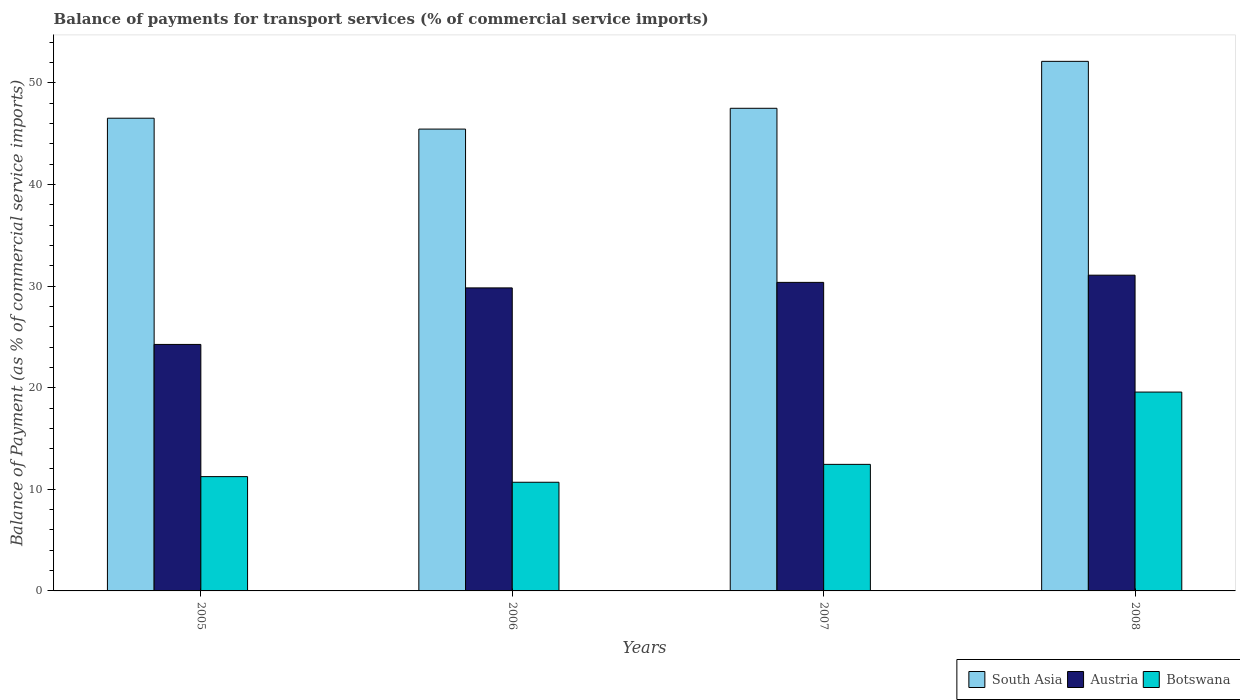How many groups of bars are there?
Keep it short and to the point. 4. Are the number of bars on each tick of the X-axis equal?
Make the answer very short. Yes. How many bars are there on the 1st tick from the left?
Your answer should be compact. 3. How many bars are there on the 4th tick from the right?
Provide a short and direct response. 3. What is the label of the 3rd group of bars from the left?
Ensure brevity in your answer.  2007. In how many cases, is the number of bars for a given year not equal to the number of legend labels?
Keep it short and to the point. 0. What is the balance of payments for transport services in South Asia in 2005?
Your response must be concise. 46.53. Across all years, what is the maximum balance of payments for transport services in South Asia?
Provide a succinct answer. 52.12. Across all years, what is the minimum balance of payments for transport services in South Asia?
Keep it short and to the point. 45.46. In which year was the balance of payments for transport services in South Asia maximum?
Make the answer very short. 2008. In which year was the balance of payments for transport services in Botswana minimum?
Give a very brief answer. 2006. What is the total balance of payments for transport services in South Asia in the graph?
Keep it short and to the point. 191.6. What is the difference between the balance of payments for transport services in Austria in 2006 and that in 2007?
Provide a succinct answer. -0.54. What is the difference between the balance of payments for transport services in Austria in 2008 and the balance of payments for transport services in Botswana in 2006?
Make the answer very short. 20.38. What is the average balance of payments for transport services in Austria per year?
Ensure brevity in your answer.  28.88. In the year 2007, what is the difference between the balance of payments for transport services in Austria and balance of payments for transport services in South Asia?
Keep it short and to the point. -17.14. In how many years, is the balance of payments for transport services in South Asia greater than 6 %?
Ensure brevity in your answer.  4. What is the ratio of the balance of payments for transport services in Austria in 2006 to that in 2007?
Your answer should be very brief. 0.98. What is the difference between the highest and the second highest balance of payments for transport services in Austria?
Your response must be concise. 0.71. What is the difference between the highest and the lowest balance of payments for transport services in Botswana?
Offer a terse response. 8.88. In how many years, is the balance of payments for transport services in Austria greater than the average balance of payments for transport services in Austria taken over all years?
Ensure brevity in your answer.  3. Is the sum of the balance of payments for transport services in Austria in 2006 and 2008 greater than the maximum balance of payments for transport services in South Asia across all years?
Offer a terse response. Yes. What does the 3rd bar from the right in 2007 represents?
Offer a terse response. South Asia. How many bars are there?
Offer a very short reply. 12. How many years are there in the graph?
Provide a short and direct response. 4. Are the values on the major ticks of Y-axis written in scientific E-notation?
Your answer should be very brief. No. Does the graph contain any zero values?
Provide a short and direct response. No. How many legend labels are there?
Make the answer very short. 3. What is the title of the graph?
Ensure brevity in your answer.  Balance of payments for transport services (% of commercial service imports). Does "Iceland" appear as one of the legend labels in the graph?
Your response must be concise. No. What is the label or title of the Y-axis?
Make the answer very short. Balance of Payment (as % of commercial service imports). What is the Balance of Payment (as % of commercial service imports) of South Asia in 2005?
Ensure brevity in your answer.  46.53. What is the Balance of Payment (as % of commercial service imports) of Austria in 2005?
Your answer should be very brief. 24.26. What is the Balance of Payment (as % of commercial service imports) in Botswana in 2005?
Offer a terse response. 11.25. What is the Balance of Payment (as % of commercial service imports) in South Asia in 2006?
Offer a very short reply. 45.46. What is the Balance of Payment (as % of commercial service imports) in Austria in 2006?
Your answer should be very brief. 29.82. What is the Balance of Payment (as % of commercial service imports) in Botswana in 2006?
Your answer should be compact. 10.7. What is the Balance of Payment (as % of commercial service imports) in South Asia in 2007?
Your answer should be compact. 47.5. What is the Balance of Payment (as % of commercial service imports) of Austria in 2007?
Make the answer very short. 30.37. What is the Balance of Payment (as % of commercial service imports) in Botswana in 2007?
Ensure brevity in your answer.  12.46. What is the Balance of Payment (as % of commercial service imports) in South Asia in 2008?
Your response must be concise. 52.12. What is the Balance of Payment (as % of commercial service imports) of Austria in 2008?
Ensure brevity in your answer.  31.08. What is the Balance of Payment (as % of commercial service imports) of Botswana in 2008?
Your answer should be compact. 19.57. Across all years, what is the maximum Balance of Payment (as % of commercial service imports) in South Asia?
Your answer should be compact. 52.12. Across all years, what is the maximum Balance of Payment (as % of commercial service imports) of Austria?
Keep it short and to the point. 31.08. Across all years, what is the maximum Balance of Payment (as % of commercial service imports) of Botswana?
Offer a very short reply. 19.57. Across all years, what is the minimum Balance of Payment (as % of commercial service imports) of South Asia?
Your answer should be very brief. 45.46. Across all years, what is the minimum Balance of Payment (as % of commercial service imports) in Austria?
Provide a short and direct response. 24.26. Across all years, what is the minimum Balance of Payment (as % of commercial service imports) in Botswana?
Your answer should be compact. 10.7. What is the total Balance of Payment (as % of commercial service imports) in South Asia in the graph?
Ensure brevity in your answer.  191.6. What is the total Balance of Payment (as % of commercial service imports) of Austria in the graph?
Your answer should be compact. 115.53. What is the total Balance of Payment (as % of commercial service imports) of Botswana in the graph?
Your response must be concise. 53.97. What is the difference between the Balance of Payment (as % of commercial service imports) of South Asia in 2005 and that in 2006?
Offer a very short reply. 1.07. What is the difference between the Balance of Payment (as % of commercial service imports) of Austria in 2005 and that in 2006?
Provide a succinct answer. -5.56. What is the difference between the Balance of Payment (as % of commercial service imports) in Botswana in 2005 and that in 2006?
Offer a very short reply. 0.56. What is the difference between the Balance of Payment (as % of commercial service imports) in South Asia in 2005 and that in 2007?
Your response must be concise. -0.98. What is the difference between the Balance of Payment (as % of commercial service imports) of Austria in 2005 and that in 2007?
Your answer should be very brief. -6.11. What is the difference between the Balance of Payment (as % of commercial service imports) in Botswana in 2005 and that in 2007?
Your answer should be very brief. -1.21. What is the difference between the Balance of Payment (as % of commercial service imports) of South Asia in 2005 and that in 2008?
Keep it short and to the point. -5.6. What is the difference between the Balance of Payment (as % of commercial service imports) of Austria in 2005 and that in 2008?
Provide a short and direct response. -6.82. What is the difference between the Balance of Payment (as % of commercial service imports) of Botswana in 2005 and that in 2008?
Your answer should be very brief. -8.32. What is the difference between the Balance of Payment (as % of commercial service imports) in South Asia in 2006 and that in 2007?
Keep it short and to the point. -2.05. What is the difference between the Balance of Payment (as % of commercial service imports) in Austria in 2006 and that in 2007?
Offer a very short reply. -0.54. What is the difference between the Balance of Payment (as % of commercial service imports) in Botswana in 2006 and that in 2007?
Provide a succinct answer. -1.76. What is the difference between the Balance of Payment (as % of commercial service imports) of South Asia in 2006 and that in 2008?
Your response must be concise. -6.67. What is the difference between the Balance of Payment (as % of commercial service imports) in Austria in 2006 and that in 2008?
Your answer should be compact. -1.25. What is the difference between the Balance of Payment (as % of commercial service imports) in Botswana in 2006 and that in 2008?
Your response must be concise. -8.88. What is the difference between the Balance of Payment (as % of commercial service imports) in South Asia in 2007 and that in 2008?
Offer a very short reply. -4.62. What is the difference between the Balance of Payment (as % of commercial service imports) in Austria in 2007 and that in 2008?
Give a very brief answer. -0.71. What is the difference between the Balance of Payment (as % of commercial service imports) in Botswana in 2007 and that in 2008?
Your answer should be very brief. -7.12. What is the difference between the Balance of Payment (as % of commercial service imports) in South Asia in 2005 and the Balance of Payment (as % of commercial service imports) in Austria in 2006?
Your response must be concise. 16.7. What is the difference between the Balance of Payment (as % of commercial service imports) of South Asia in 2005 and the Balance of Payment (as % of commercial service imports) of Botswana in 2006?
Ensure brevity in your answer.  35.83. What is the difference between the Balance of Payment (as % of commercial service imports) in Austria in 2005 and the Balance of Payment (as % of commercial service imports) in Botswana in 2006?
Offer a terse response. 13.57. What is the difference between the Balance of Payment (as % of commercial service imports) of South Asia in 2005 and the Balance of Payment (as % of commercial service imports) of Austria in 2007?
Make the answer very short. 16.16. What is the difference between the Balance of Payment (as % of commercial service imports) in South Asia in 2005 and the Balance of Payment (as % of commercial service imports) in Botswana in 2007?
Provide a succinct answer. 34.07. What is the difference between the Balance of Payment (as % of commercial service imports) in Austria in 2005 and the Balance of Payment (as % of commercial service imports) in Botswana in 2007?
Provide a succinct answer. 11.8. What is the difference between the Balance of Payment (as % of commercial service imports) in South Asia in 2005 and the Balance of Payment (as % of commercial service imports) in Austria in 2008?
Ensure brevity in your answer.  15.45. What is the difference between the Balance of Payment (as % of commercial service imports) of South Asia in 2005 and the Balance of Payment (as % of commercial service imports) of Botswana in 2008?
Provide a short and direct response. 26.95. What is the difference between the Balance of Payment (as % of commercial service imports) in Austria in 2005 and the Balance of Payment (as % of commercial service imports) in Botswana in 2008?
Your answer should be compact. 4.69. What is the difference between the Balance of Payment (as % of commercial service imports) in South Asia in 2006 and the Balance of Payment (as % of commercial service imports) in Austria in 2007?
Offer a very short reply. 15.09. What is the difference between the Balance of Payment (as % of commercial service imports) in South Asia in 2006 and the Balance of Payment (as % of commercial service imports) in Botswana in 2007?
Make the answer very short. 33. What is the difference between the Balance of Payment (as % of commercial service imports) in Austria in 2006 and the Balance of Payment (as % of commercial service imports) in Botswana in 2007?
Ensure brevity in your answer.  17.37. What is the difference between the Balance of Payment (as % of commercial service imports) in South Asia in 2006 and the Balance of Payment (as % of commercial service imports) in Austria in 2008?
Your answer should be very brief. 14.38. What is the difference between the Balance of Payment (as % of commercial service imports) of South Asia in 2006 and the Balance of Payment (as % of commercial service imports) of Botswana in 2008?
Your answer should be compact. 25.88. What is the difference between the Balance of Payment (as % of commercial service imports) in Austria in 2006 and the Balance of Payment (as % of commercial service imports) in Botswana in 2008?
Offer a terse response. 10.25. What is the difference between the Balance of Payment (as % of commercial service imports) of South Asia in 2007 and the Balance of Payment (as % of commercial service imports) of Austria in 2008?
Your answer should be very brief. 16.43. What is the difference between the Balance of Payment (as % of commercial service imports) in South Asia in 2007 and the Balance of Payment (as % of commercial service imports) in Botswana in 2008?
Your answer should be compact. 27.93. What is the difference between the Balance of Payment (as % of commercial service imports) of Austria in 2007 and the Balance of Payment (as % of commercial service imports) of Botswana in 2008?
Make the answer very short. 10.79. What is the average Balance of Payment (as % of commercial service imports) of South Asia per year?
Ensure brevity in your answer.  47.9. What is the average Balance of Payment (as % of commercial service imports) in Austria per year?
Provide a short and direct response. 28.88. What is the average Balance of Payment (as % of commercial service imports) of Botswana per year?
Provide a succinct answer. 13.49. In the year 2005, what is the difference between the Balance of Payment (as % of commercial service imports) in South Asia and Balance of Payment (as % of commercial service imports) in Austria?
Provide a short and direct response. 22.26. In the year 2005, what is the difference between the Balance of Payment (as % of commercial service imports) in South Asia and Balance of Payment (as % of commercial service imports) in Botswana?
Make the answer very short. 35.27. In the year 2005, what is the difference between the Balance of Payment (as % of commercial service imports) in Austria and Balance of Payment (as % of commercial service imports) in Botswana?
Your answer should be compact. 13.01. In the year 2006, what is the difference between the Balance of Payment (as % of commercial service imports) of South Asia and Balance of Payment (as % of commercial service imports) of Austria?
Your answer should be compact. 15.63. In the year 2006, what is the difference between the Balance of Payment (as % of commercial service imports) in South Asia and Balance of Payment (as % of commercial service imports) in Botswana?
Make the answer very short. 34.76. In the year 2006, what is the difference between the Balance of Payment (as % of commercial service imports) in Austria and Balance of Payment (as % of commercial service imports) in Botswana?
Your answer should be compact. 19.13. In the year 2007, what is the difference between the Balance of Payment (as % of commercial service imports) of South Asia and Balance of Payment (as % of commercial service imports) of Austria?
Your answer should be very brief. 17.14. In the year 2007, what is the difference between the Balance of Payment (as % of commercial service imports) of South Asia and Balance of Payment (as % of commercial service imports) of Botswana?
Offer a terse response. 35.05. In the year 2007, what is the difference between the Balance of Payment (as % of commercial service imports) of Austria and Balance of Payment (as % of commercial service imports) of Botswana?
Make the answer very short. 17.91. In the year 2008, what is the difference between the Balance of Payment (as % of commercial service imports) in South Asia and Balance of Payment (as % of commercial service imports) in Austria?
Offer a very short reply. 21.05. In the year 2008, what is the difference between the Balance of Payment (as % of commercial service imports) of South Asia and Balance of Payment (as % of commercial service imports) of Botswana?
Give a very brief answer. 32.55. In the year 2008, what is the difference between the Balance of Payment (as % of commercial service imports) of Austria and Balance of Payment (as % of commercial service imports) of Botswana?
Provide a succinct answer. 11.5. What is the ratio of the Balance of Payment (as % of commercial service imports) in South Asia in 2005 to that in 2006?
Your answer should be compact. 1.02. What is the ratio of the Balance of Payment (as % of commercial service imports) of Austria in 2005 to that in 2006?
Provide a short and direct response. 0.81. What is the ratio of the Balance of Payment (as % of commercial service imports) of Botswana in 2005 to that in 2006?
Make the answer very short. 1.05. What is the ratio of the Balance of Payment (as % of commercial service imports) in South Asia in 2005 to that in 2007?
Offer a very short reply. 0.98. What is the ratio of the Balance of Payment (as % of commercial service imports) of Austria in 2005 to that in 2007?
Your response must be concise. 0.8. What is the ratio of the Balance of Payment (as % of commercial service imports) of Botswana in 2005 to that in 2007?
Ensure brevity in your answer.  0.9. What is the ratio of the Balance of Payment (as % of commercial service imports) in South Asia in 2005 to that in 2008?
Your response must be concise. 0.89. What is the ratio of the Balance of Payment (as % of commercial service imports) in Austria in 2005 to that in 2008?
Provide a succinct answer. 0.78. What is the ratio of the Balance of Payment (as % of commercial service imports) of Botswana in 2005 to that in 2008?
Keep it short and to the point. 0.57. What is the ratio of the Balance of Payment (as % of commercial service imports) of South Asia in 2006 to that in 2007?
Ensure brevity in your answer.  0.96. What is the ratio of the Balance of Payment (as % of commercial service imports) of Austria in 2006 to that in 2007?
Your answer should be very brief. 0.98. What is the ratio of the Balance of Payment (as % of commercial service imports) in Botswana in 2006 to that in 2007?
Provide a short and direct response. 0.86. What is the ratio of the Balance of Payment (as % of commercial service imports) in South Asia in 2006 to that in 2008?
Ensure brevity in your answer.  0.87. What is the ratio of the Balance of Payment (as % of commercial service imports) in Austria in 2006 to that in 2008?
Offer a very short reply. 0.96. What is the ratio of the Balance of Payment (as % of commercial service imports) in Botswana in 2006 to that in 2008?
Offer a very short reply. 0.55. What is the ratio of the Balance of Payment (as % of commercial service imports) in South Asia in 2007 to that in 2008?
Your response must be concise. 0.91. What is the ratio of the Balance of Payment (as % of commercial service imports) in Austria in 2007 to that in 2008?
Provide a succinct answer. 0.98. What is the ratio of the Balance of Payment (as % of commercial service imports) of Botswana in 2007 to that in 2008?
Provide a succinct answer. 0.64. What is the difference between the highest and the second highest Balance of Payment (as % of commercial service imports) of South Asia?
Your answer should be compact. 4.62. What is the difference between the highest and the second highest Balance of Payment (as % of commercial service imports) in Austria?
Your answer should be compact. 0.71. What is the difference between the highest and the second highest Balance of Payment (as % of commercial service imports) in Botswana?
Give a very brief answer. 7.12. What is the difference between the highest and the lowest Balance of Payment (as % of commercial service imports) of South Asia?
Offer a terse response. 6.67. What is the difference between the highest and the lowest Balance of Payment (as % of commercial service imports) of Austria?
Your response must be concise. 6.82. What is the difference between the highest and the lowest Balance of Payment (as % of commercial service imports) of Botswana?
Your answer should be compact. 8.88. 